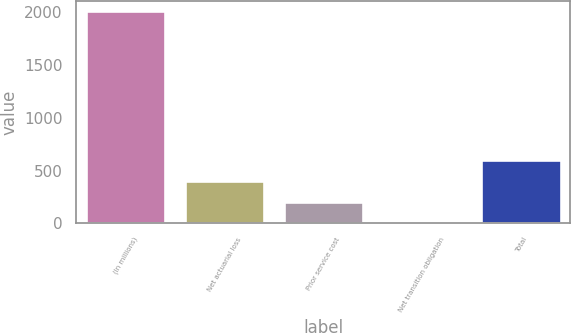<chart> <loc_0><loc_0><loc_500><loc_500><bar_chart><fcel>(In millions)<fcel>Net actuarial loss<fcel>Prior service cost<fcel>Net transition obligation<fcel>Total<nl><fcel>2011<fcel>403<fcel>202<fcel>1<fcel>604<nl></chart> 